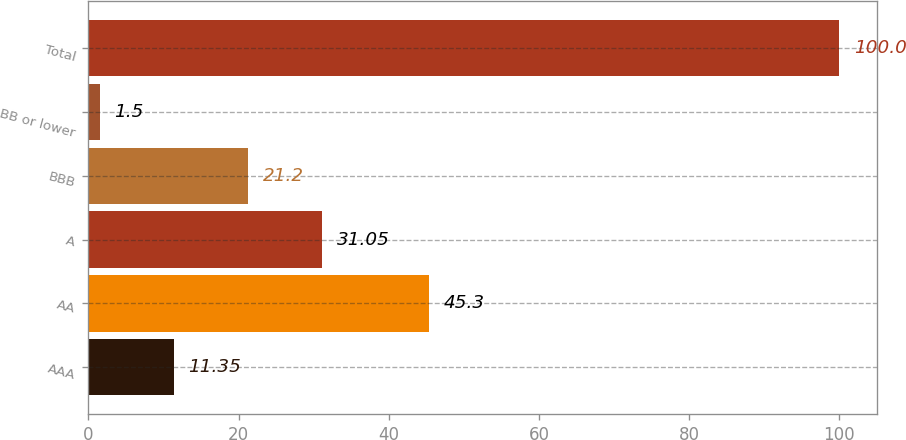Convert chart to OTSL. <chart><loc_0><loc_0><loc_500><loc_500><bar_chart><fcel>AAA<fcel>AA<fcel>A<fcel>BBB<fcel>BB or lower<fcel>Total<nl><fcel>11.35<fcel>45.3<fcel>31.05<fcel>21.2<fcel>1.5<fcel>100<nl></chart> 